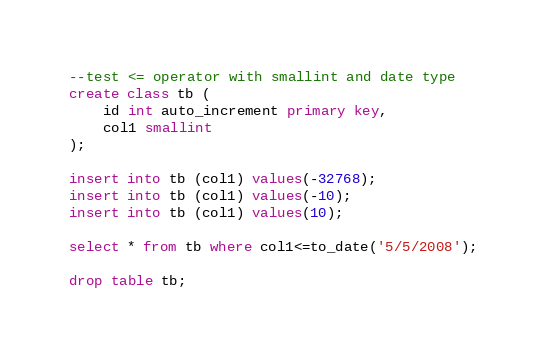Convert code to text. <code><loc_0><loc_0><loc_500><loc_500><_SQL_>--test <= operator with smallint and date type
create class tb ( 
	id int auto_increment primary key,
	col1 smallint
);

insert into tb (col1) values(-32768);
insert into tb (col1) values(-10);
insert into tb (col1) values(10);

select * from tb where col1<=to_date('5/5/2008');

drop table tb;</code> 